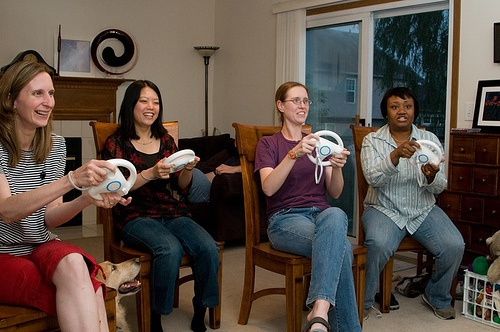Describe the objects in this image and their specific colors. I can see people in gray, maroon, black, and tan tones, people in gray, black, blue, and maroon tones, people in gray, black, maroon, brown, and tan tones, people in gray, black, darkgray, and blue tones, and chair in gray, maroon, and black tones in this image. 